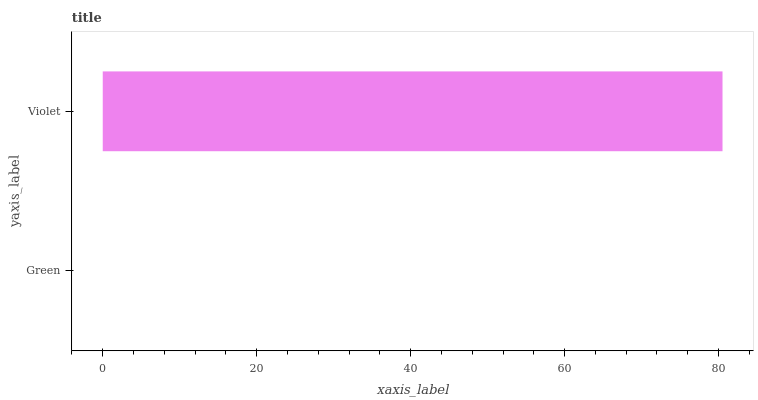Is Green the minimum?
Answer yes or no. Yes. Is Violet the maximum?
Answer yes or no. Yes. Is Violet the minimum?
Answer yes or no. No. Is Violet greater than Green?
Answer yes or no. Yes. Is Green less than Violet?
Answer yes or no. Yes. Is Green greater than Violet?
Answer yes or no. No. Is Violet less than Green?
Answer yes or no. No. Is Violet the high median?
Answer yes or no. Yes. Is Green the low median?
Answer yes or no. Yes. Is Green the high median?
Answer yes or no. No. Is Violet the low median?
Answer yes or no. No. 